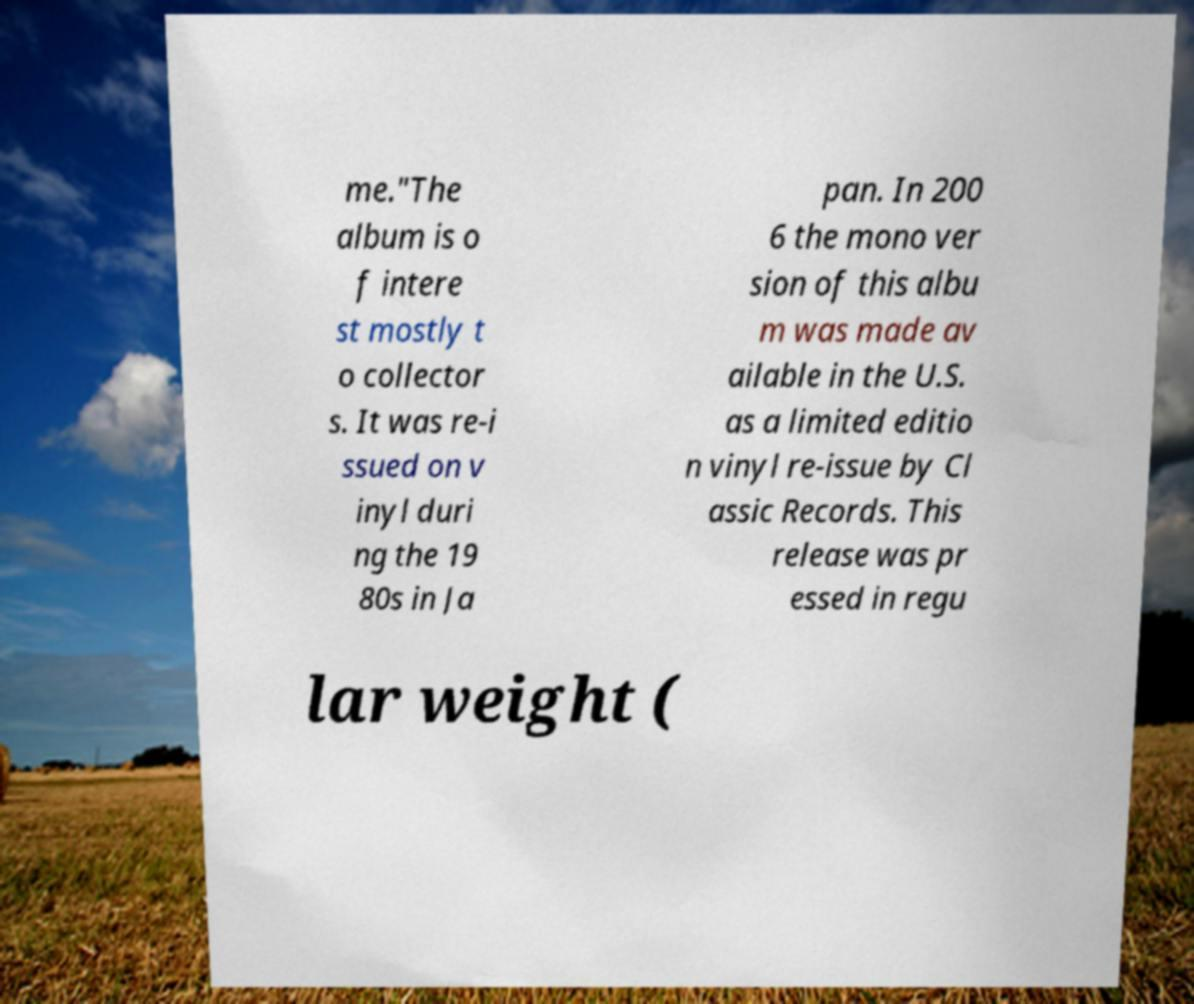I need the written content from this picture converted into text. Can you do that? me."The album is o f intere st mostly t o collector s. It was re-i ssued on v inyl duri ng the 19 80s in Ja pan. In 200 6 the mono ver sion of this albu m was made av ailable in the U.S. as a limited editio n vinyl re-issue by Cl assic Records. This release was pr essed in regu lar weight ( 